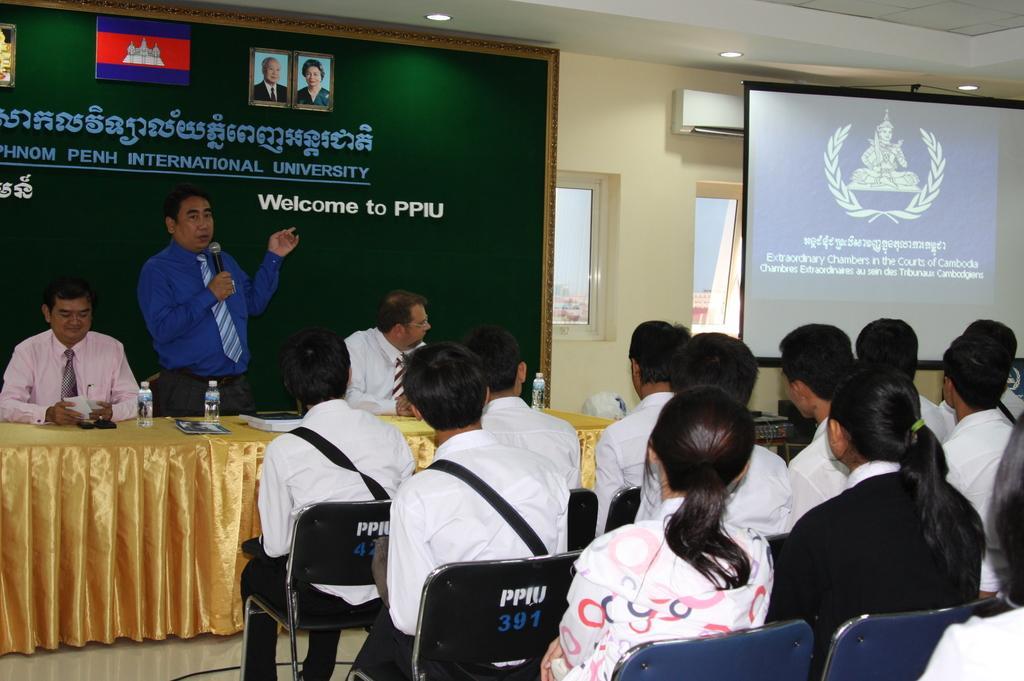In one or two sentences, can you explain what this image depicts? This picture is taken inside the hall where we can see there is a man in the middle who is holding the mic. In front of him there is a table on which there are bottles and papers. There are two persons beside him. At the bottom there are so many people sitting on the chairs. On the right side top there is a projector screen. At the top there is ceiling with the lights. In the background there is a hoarding. Behind the screen there is an air conditioner. 